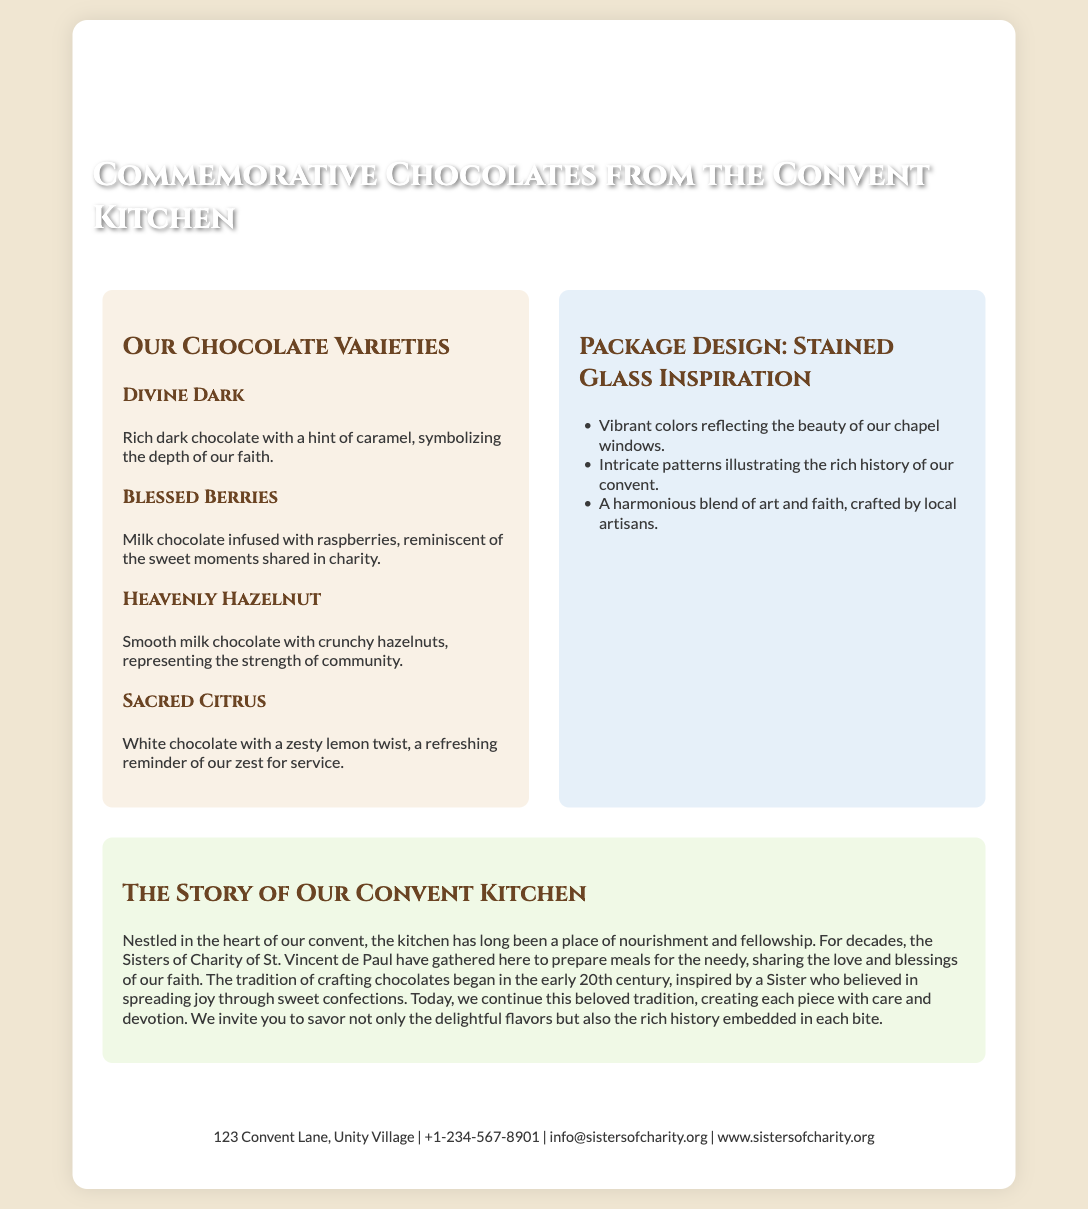What is the name of the product? The product is named "Commemorative Chocolates from the Convent Kitchen," as stated in the title.
Answer: Commemorative Chocolates from the Convent Kitchen How many varieties of chocolates are mentioned? There are four varieties of chocolates listed in the document.
Answer: Four What is the flavor of the "Divine Dark" chocolate? The flavor of "Divine Dark" chocolate is described as rich dark chocolate with a hint of caramel.
Answer: Rich dark chocolate with a hint of caramel What does the package design reflect? The package design reflects vibrant colors and intricate patterns illustrating the history of the convent.
Answer: Vibrant colors and intricate patterns Who inspired the tradition of crafting chocolates? The tradition was inspired by a Sister who believed in spreading joy through sweet confections.
Answer: A Sister What is the address of the convent? The address of the convent is provided in the contact section of the document.
Answer: 123 Convent Lane, Unity Village What type of document is presented here? This document is a product packaging, specifically for a chocolate product.
Answer: Product packaging What is the meaning of "Sacred Citrus" chocolate? The "Sacred Citrus" chocolate is described as white chocolate with a zesty lemon twist.
Answer: White chocolate with a zesty lemon twist What does "Heavenly Hazelnut" represent? The "Heavenly Hazelnut" represents the strength of community according to the description.
Answer: The strength of community 